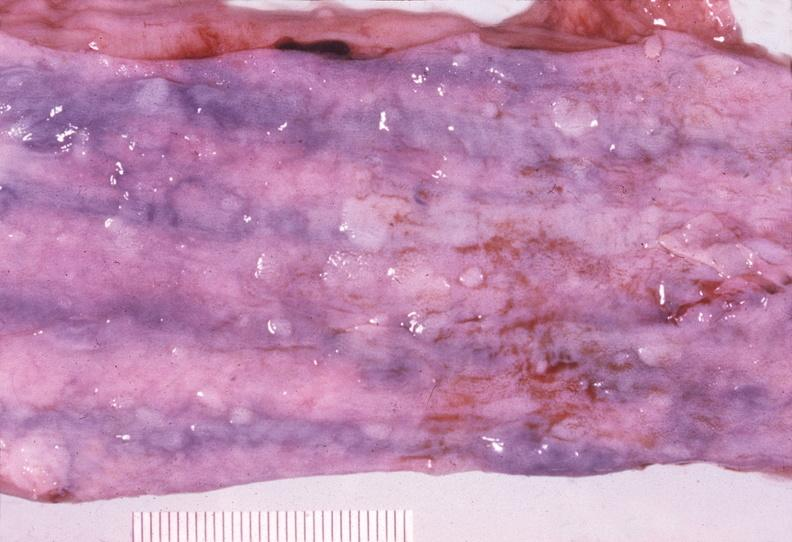what does this image show?
Answer the question using a single word or phrase. Esophagus 